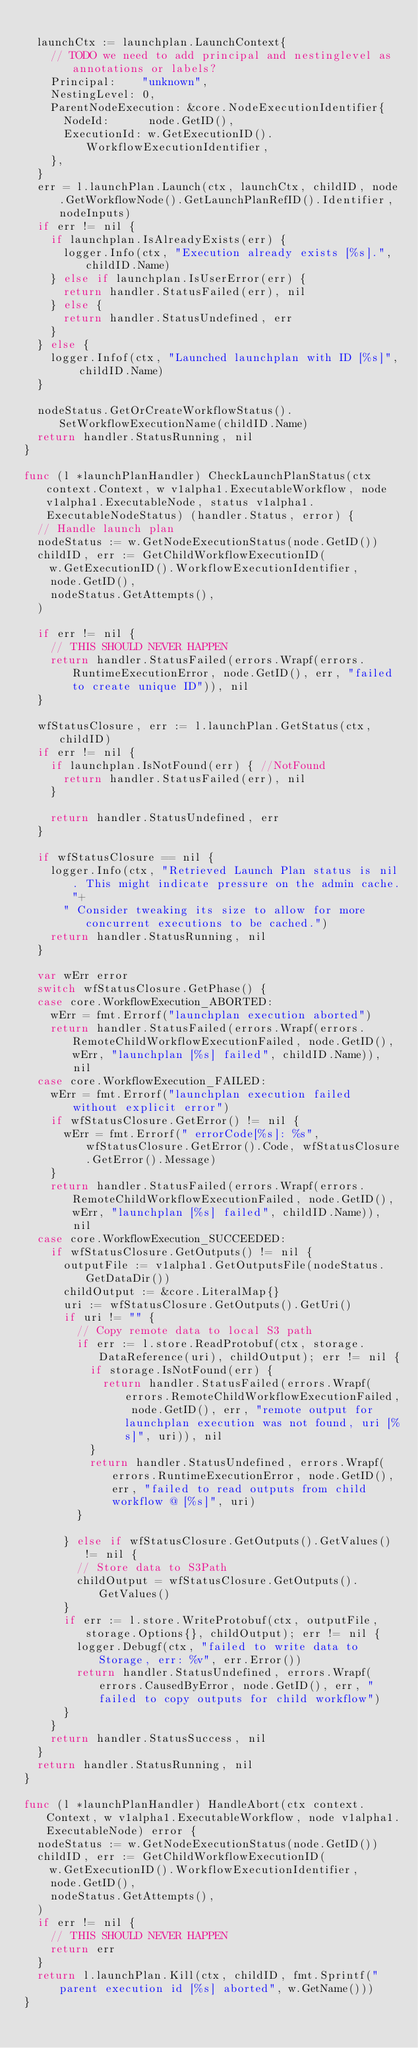<code> <loc_0><loc_0><loc_500><loc_500><_Go_>
	launchCtx := launchplan.LaunchContext{
		// TODO we need to add principal and nestinglevel as annotations or labels?
		Principal:    "unknown",
		NestingLevel: 0,
		ParentNodeExecution: &core.NodeExecutionIdentifier{
			NodeId:      node.GetID(),
			ExecutionId: w.GetExecutionID().WorkflowExecutionIdentifier,
		},
	}
	err = l.launchPlan.Launch(ctx, launchCtx, childID, node.GetWorkflowNode().GetLaunchPlanRefID().Identifier, nodeInputs)
	if err != nil {
		if launchplan.IsAlreadyExists(err) {
			logger.Info(ctx, "Execution already exists [%s].", childID.Name)
		} else if launchplan.IsUserError(err) {
			return handler.StatusFailed(err), nil
		} else {
			return handler.StatusUndefined, err
		}
	} else {
		logger.Infof(ctx, "Launched launchplan with ID [%s]", childID.Name)
	}

	nodeStatus.GetOrCreateWorkflowStatus().SetWorkflowExecutionName(childID.Name)
	return handler.StatusRunning, nil
}

func (l *launchPlanHandler) CheckLaunchPlanStatus(ctx context.Context, w v1alpha1.ExecutableWorkflow, node v1alpha1.ExecutableNode, status v1alpha1.ExecutableNodeStatus) (handler.Status, error) {
	// Handle launch plan
	nodeStatus := w.GetNodeExecutionStatus(node.GetID())
	childID, err := GetChildWorkflowExecutionID(
		w.GetExecutionID().WorkflowExecutionIdentifier,
		node.GetID(),
		nodeStatus.GetAttempts(),
	)

	if err != nil {
		// THIS SHOULD NEVER HAPPEN
		return handler.StatusFailed(errors.Wrapf(errors.RuntimeExecutionError, node.GetID(), err, "failed to create unique ID")), nil
	}

	wfStatusClosure, err := l.launchPlan.GetStatus(ctx, childID)
	if err != nil {
		if launchplan.IsNotFound(err) { //NotFound
			return handler.StatusFailed(err), nil
		}

		return handler.StatusUndefined, err
	}

	if wfStatusClosure == nil {
		logger.Info(ctx, "Retrieved Launch Plan status is nil. This might indicate pressure on the admin cache."+
			" Consider tweaking its size to allow for more concurrent executions to be cached.")
		return handler.StatusRunning, nil
	}

	var wErr error
	switch wfStatusClosure.GetPhase() {
	case core.WorkflowExecution_ABORTED:
		wErr = fmt.Errorf("launchplan execution aborted")
		return handler.StatusFailed(errors.Wrapf(errors.RemoteChildWorkflowExecutionFailed, node.GetID(), wErr, "launchplan [%s] failed", childID.Name)), nil
	case core.WorkflowExecution_FAILED:
		wErr = fmt.Errorf("launchplan execution failed without explicit error")
		if wfStatusClosure.GetError() != nil {
			wErr = fmt.Errorf(" errorCode[%s]: %s", wfStatusClosure.GetError().Code, wfStatusClosure.GetError().Message)
		}
		return handler.StatusFailed(errors.Wrapf(errors.RemoteChildWorkflowExecutionFailed, node.GetID(), wErr, "launchplan [%s] failed", childID.Name)), nil
	case core.WorkflowExecution_SUCCEEDED:
		if wfStatusClosure.GetOutputs() != nil {
			outputFile := v1alpha1.GetOutputsFile(nodeStatus.GetDataDir())
			childOutput := &core.LiteralMap{}
			uri := wfStatusClosure.GetOutputs().GetUri()
			if uri != "" {
				// Copy remote data to local S3 path
				if err := l.store.ReadProtobuf(ctx, storage.DataReference(uri), childOutput); err != nil {
					if storage.IsNotFound(err) {
						return handler.StatusFailed(errors.Wrapf(errors.RemoteChildWorkflowExecutionFailed, node.GetID(), err, "remote output for launchplan execution was not found, uri [%s]", uri)), nil
					}
					return handler.StatusUndefined, errors.Wrapf(errors.RuntimeExecutionError, node.GetID(), err, "failed to read outputs from child workflow @ [%s]", uri)
				}

			} else if wfStatusClosure.GetOutputs().GetValues() != nil {
				// Store data to S3Path
				childOutput = wfStatusClosure.GetOutputs().GetValues()
			}
			if err := l.store.WriteProtobuf(ctx, outputFile, storage.Options{}, childOutput); err != nil {
				logger.Debugf(ctx, "failed to write data to Storage, err: %v", err.Error())
				return handler.StatusUndefined, errors.Wrapf(errors.CausedByError, node.GetID(), err, "failed to copy outputs for child workflow")
			}
		}
		return handler.StatusSuccess, nil
	}
	return handler.StatusRunning, nil
}

func (l *launchPlanHandler) HandleAbort(ctx context.Context, w v1alpha1.ExecutableWorkflow, node v1alpha1.ExecutableNode) error {
	nodeStatus := w.GetNodeExecutionStatus(node.GetID())
	childID, err := GetChildWorkflowExecutionID(
		w.GetExecutionID().WorkflowExecutionIdentifier,
		node.GetID(),
		nodeStatus.GetAttempts(),
	)
	if err != nil {
		// THIS SHOULD NEVER HAPPEN
		return err
	}
	return l.launchPlan.Kill(ctx, childID, fmt.Sprintf("parent execution id [%s] aborted", w.GetName()))
}
</code> 